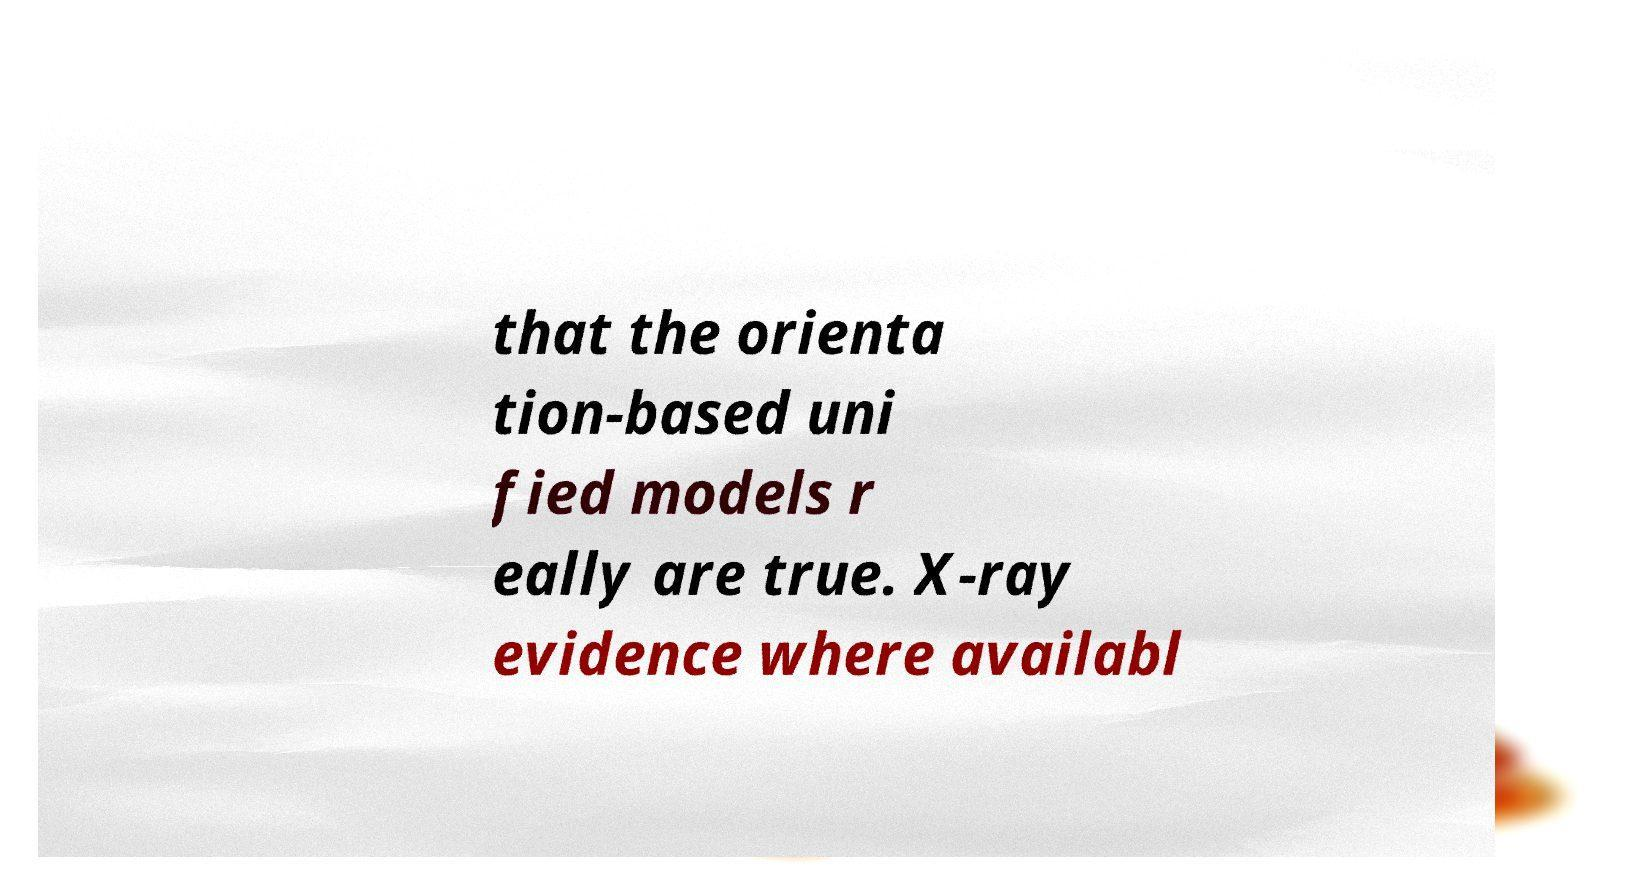For documentation purposes, I need the text within this image transcribed. Could you provide that? that the orienta tion-based uni fied models r eally are true. X-ray evidence where availabl 